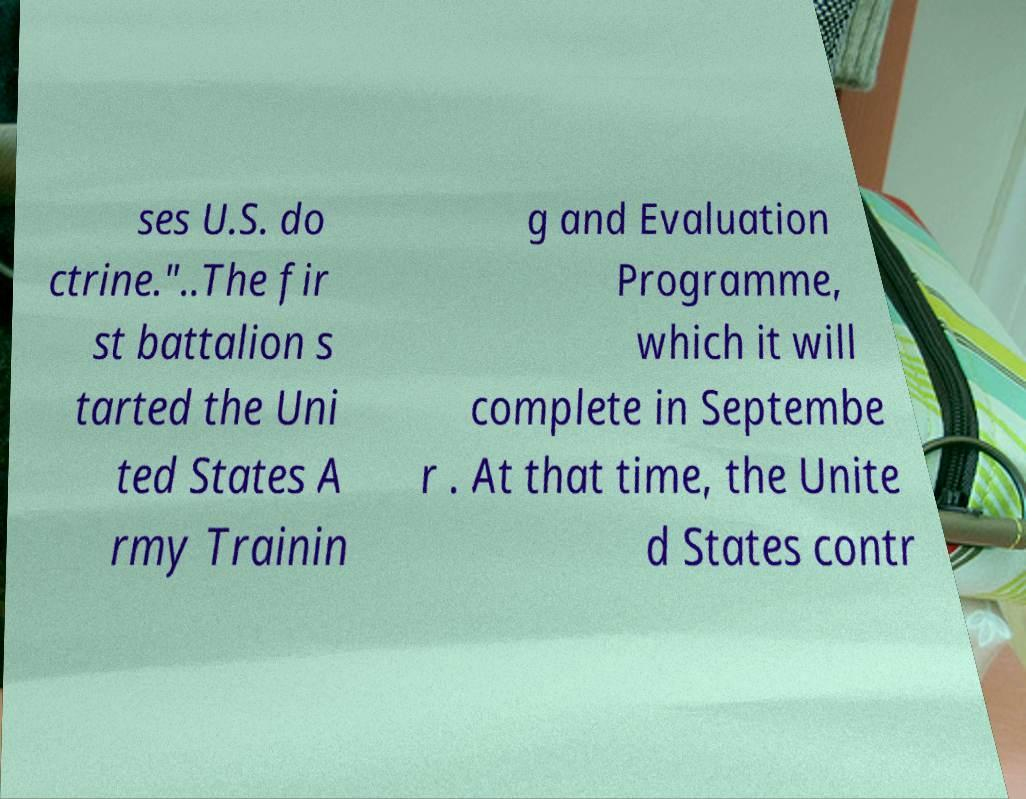I need the written content from this picture converted into text. Can you do that? ses U.S. do ctrine."..The fir st battalion s tarted the Uni ted States A rmy Trainin g and Evaluation Programme, which it will complete in Septembe r . At that time, the Unite d States contr 